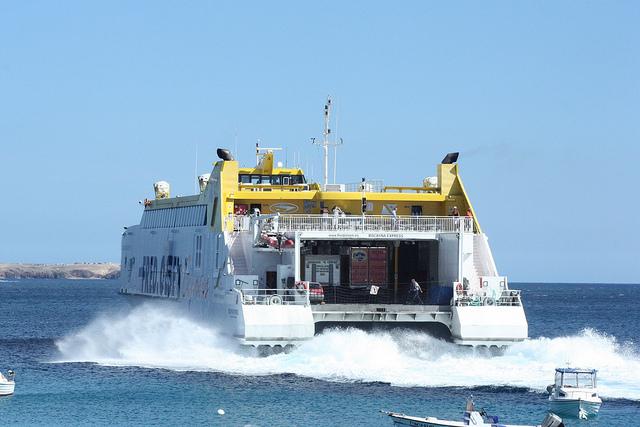Why is there a antenna on top of the boat?
Concise answer only. Radio communication. Are there smaller boats around?
Answer briefly. Yes. Is this a cruise ship?
Short answer required. No. 